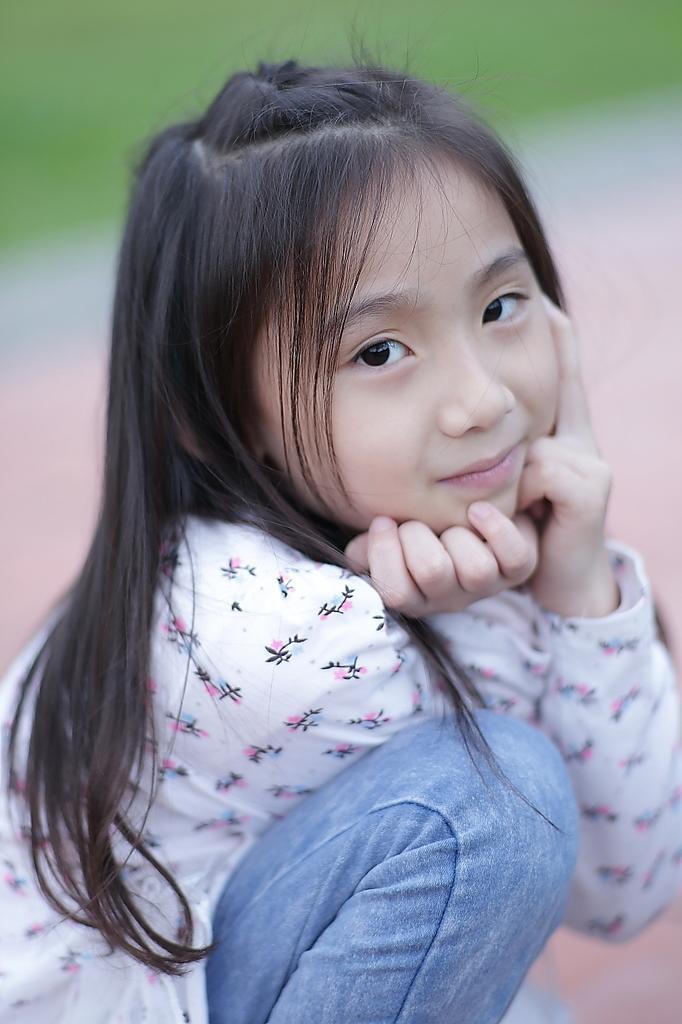Describe this image in one or two sentences. In this picture I can see a girl, and there is blur background. 